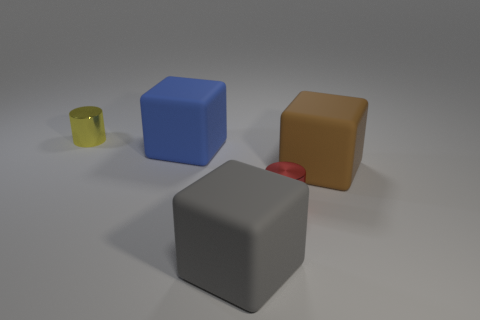Are there any red metallic cylinders that are on the left side of the tiny metallic thing on the right side of the big blue rubber block on the right side of the small yellow metal cylinder?
Your answer should be compact. No. Are there any big brown blocks?
Provide a succinct answer. Yes. Is the number of things that are to the right of the brown cube greater than the number of large matte objects that are in front of the blue matte object?
Your answer should be very brief. No. What is the size of the blue thing that is the same material as the big gray thing?
Offer a very short reply. Large. What size is the gray rubber block to the left of the small cylinder in front of the big matte block right of the tiny red metal cylinder?
Provide a short and direct response. Large. There is a large thing that is behind the brown cube; what is its color?
Your answer should be compact. Blue. Is the number of large brown blocks to the right of the big brown matte thing greater than the number of small yellow metal objects?
Your answer should be compact. No. Does the metal thing behind the tiny red thing have the same shape as the big gray thing?
Keep it short and to the point. No. What number of cyan objects are big cubes or small metal cylinders?
Give a very brief answer. 0. Are there more small cyan metallic cylinders than metal things?
Give a very brief answer. No. 